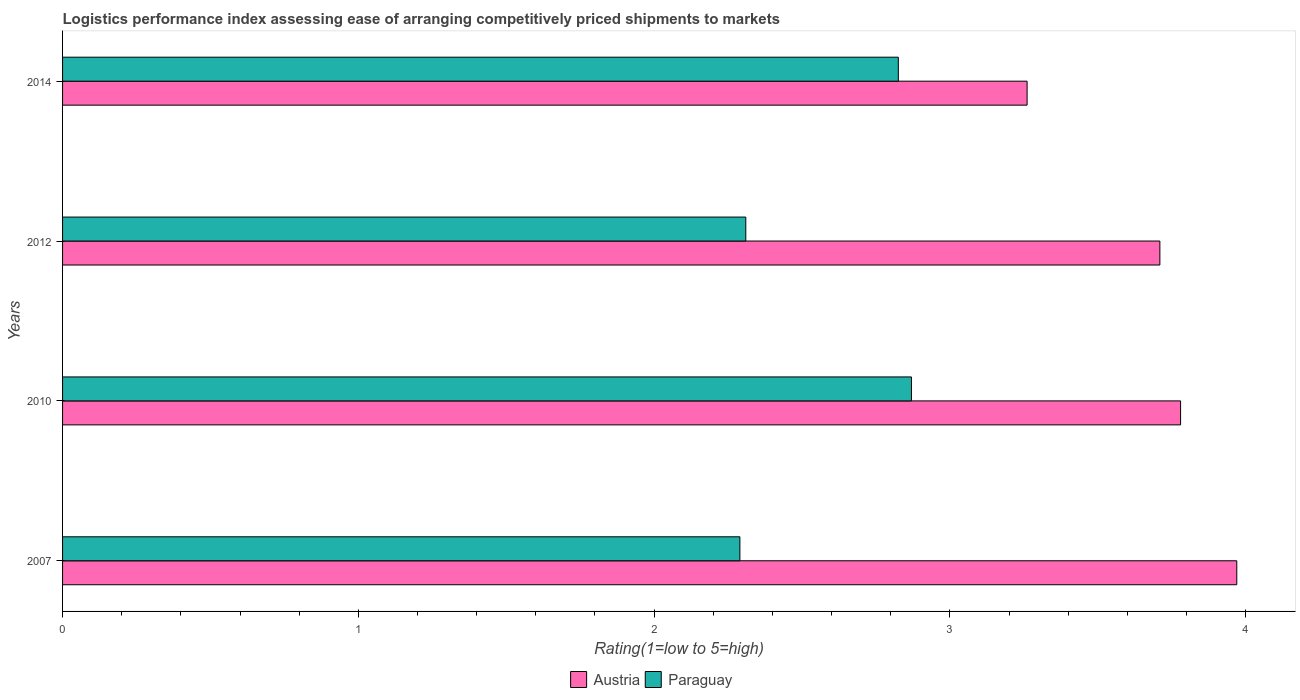How many groups of bars are there?
Ensure brevity in your answer.  4. Are the number of bars on each tick of the Y-axis equal?
Provide a succinct answer. Yes. In how many cases, is the number of bars for a given year not equal to the number of legend labels?
Offer a terse response. 0. What is the Logistic performance index in Paraguay in 2012?
Your answer should be very brief. 2.31. Across all years, what is the maximum Logistic performance index in Austria?
Your response must be concise. 3.97. Across all years, what is the minimum Logistic performance index in Austria?
Offer a terse response. 3.26. In which year was the Logistic performance index in Austria minimum?
Offer a terse response. 2014. What is the total Logistic performance index in Paraguay in the graph?
Your answer should be compact. 10.3. What is the difference between the Logistic performance index in Paraguay in 2007 and that in 2012?
Offer a very short reply. -0.02. What is the difference between the Logistic performance index in Paraguay in 2014 and the Logistic performance index in Austria in 2007?
Offer a terse response. -1.14. What is the average Logistic performance index in Austria per year?
Your answer should be compact. 3.68. In the year 2012, what is the difference between the Logistic performance index in Austria and Logistic performance index in Paraguay?
Offer a terse response. 1.4. In how many years, is the Logistic performance index in Paraguay greater than 0.4 ?
Give a very brief answer. 4. What is the ratio of the Logistic performance index in Austria in 2012 to that in 2014?
Your answer should be very brief. 1.14. Is the Logistic performance index in Paraguay in 2007 less than that in 2010?
Offer a terse response. Yes. Is the difference between the Logistic performance index in Austria in 2010 and 2014 greater than the difference between the Logistic performance index in Paraguay in 2010 and 2014?
Provide a succinct answer. Yes. What is the difference between the highest and the second highest Logistic performance index in Paraguay?
Your answer should be very brief. 0.04. What is the difference between the highest and the lowest Logistic performance index in Paraguay?
Offer a terse response. 0.58. In how many years, is the Logistic performance index in Paraguay greater than the average Logistic performance index in Paraguay taken over all years?
Your answer should be compact. 2. What does the 1st bar from the top in 2014 represents?
Offer a terse response. Paraguay. What does the 1st bar from the bottom in 2007 represents?
Provide a short and direct response. Austria. How many bars are there?
Your response must be concise. 8. How many years are there in the graph?
Give a very brief answer. 4. What is the difference between two consecutive major ticks on the X-axis?
Give a very brief answer. 1. Does the graph contain any zero values?
Provide a succinct answer. No. Does the graph contain grids?
Offer a very short reply. No. Where does the legend appear in the graph?
Provide a short and direct response. Bottom center. What is the title of the graph?
Provide a succinct answer. Logistics performance index assessing ease of arranging competitively priced shipments to markets. Does "Senegal" appear as one of the legend labels in the graph?
Your response must be concise. No. What is the label or title of the X-axis?
Ensure brevity in your answer.  Rating(1=low to 5=high). What is the Rating(1=low to 5=high) of Austria in 2007?
Ensure brevity in your answer.  3.97. What is the Rating(1=low to 5=high) of Paraguay in 2007?
Keep it short and to the point. 2.29. What is the Rating(1=low to 5=high) in Austria in 2010?
Your answer should be very brief. 3.78. What is the Rating(1=low to 5=high) of Paraguay in 2010?
Offer a very short reply. 2.87. What is the Rating(1=low to 5=high) in Austria in 2012?
Offer a very short reply. 3.71. What is the Rating(1=low to 5=high) in Paraguay in 2012?
Your response must be concise. 2.31. What is the Rating(1=low to 5=high) of Austria in 2014?
Ensure brevity in your answer.  3.26. What is the Rating(1=low to 5=high) in Paraguay in 2014?
Provide a succinct answer. 2.83. Across all years, what is the maximum Rating(1=low to 5=high) of Austria?
Give a very brief answer. 3.97. Across all years, what is the maximum Rating(1=low to 5=high) of Paraguay?
Provide a succinct answer. 2.87. Across all years, what is the minimum Rating(1=low to 5=high) in Austria?
Offer a very short reply. 3.26. Across all years, what is the minimum Rating(1=low to 5=high) of Paraguay?
Make the answer very short. 2.29. What is the total Rating(1=low to 5=high) in Austria in the graph?
Your answer should be very brief. 14.72. What is the total Rating(1=low to 5=high) of Paraguay in the graph?
Your response must be concise. 10.3. What is the difference between the Rating(1=low to 5=high) of Austria in 2007 and that in 2010?
Your answer should be very brief. 0.19. What is the difference between the Rating(1=low to 5=high) in Paraguay in 2007 and that in 2010?
Give a very brief answer. -0.58. What is the difference between the Rating(1=low to 5=high) in Austria in 2007 and that in 2012?
Your response must be concise. 0.26. What is the difference between the Rating(1=low to 5=high) of Paraguay in 2007 and that in 2012?
Ensure brevity in your answer.  -0.02. What is the difference between the Rating(1=low to 5=high) in Austria in 2007 and that in 2014?
Provide a succinct answer. 0.71. What is the difference between the Rating(1=low to 5=high) of Paraguay in 2007 and that in 2014?
Ensure brevity in your answer.  -0.54. What is the difference between the Rating(1=low to 5=high) of Austria in 2010 and that in 2012?
Keep it short and to the point. 0.07. What is the difference between the Rating(1=low to 5=high) of Paraguay in 2010 and that in 2012?
Your response must be concise. 0.56. What is the difference between the Rating(1=low to 5=high) in Austria in 2010 and that in 2014?
Make the answer very short. 0.52. What is the difference between the Rating(1=low to 5=high) in Paraguay in 2010 and that in 2014?
Your answer should be very brief. 0.04. What is the difference between the Rating(1=low to 5=high) in Austria in 2012 and that in 2014?
Make the answer very short. 0.45. What is the difference between the Rating(1=low to 5=high) of Paraguay in 2012 and that in 2014?
Ensure brevity in your answer.  -0.52. What is the difference between the Rating(1=low to 5=high) in Austria in 2007 and the Rating(1=low to 5=high) in Paraguay in 2012?
Offer a terse response. 1.66. What is the difference between the Rating(1=low to 5=high) in Austria in 2007 and the Rating(1=low to 5=high) in Paraguay in 2014?
Keep it short and to the point. 1.14. What is the difference between the Rating(1=low to 5=high) of Austria in 2010 and the Rating(1=low to 5=high) of Paraguay in 2012?
Your response must be concise. 1.47. What is the difference between the Rating(1=low to 5=high) in Austria in 2010 and the Rating(1=low to 5=high) in Paraguay in 2014?
Give a very brief answer. 0.95. What is the difference between the Rating(1=low to 5=high) in Austria in 2012 and the Rating(1=low to 5=high) in Paraguay in 2014?
Offer a terse response. 0.88. What is the average Rating(1=low to 5=high) in Austria per year?
Ensure brevity in your answer.  3.68. What is the average Rating(1=low to 5=high) in Paraguay per year?
Ensure brevity in your answer.  2.57. In the year 2007, what is the difference between the Rating(1=low to 5=high) in Austria and Rating(1=low to 5=high) in Paraguay?
Ensure brevity in your answer.  1.68. In the year 2010, what is the difference between the Rating(1=low to 5=high) in Austria and Rating(1=low to 5=high) in Paraguay?
Ensure brevity in your answer.  0.91. In the year 2014, what is the difference between the Rating(1=low to 5=high) of Austria and Rating(1=low to 5=high) of Paraguay?
Provide a short and direct response. 0.44. What is the ratio of the Rating(1=low to 5=high) of Austria in 2007 to that in 2010?
Your answer should be compact. 1.05. What is the ratio of the Rating(1=low to 5=high) in Paraguay in 2007 to that in 2010?
Your answer should be very brief. 0.8. What is the ratio of the Rating(1=low to 5=high) in Austria in 2007 to that in 2012?
Make the answer very short. 1.07. What is the ratio of the Rating(1=low to 5=high) in Austria in 2007 to that in 2014?
Give a very brief answer. 1.22. What is the ratio of the Rating(1=low to 5=high) in Paraguay in 2007 to that in 2014?
Make the answer very short. 0.81. What is the ratio of the Rating(1=low to 5=high) of Austria in 2010 to that in 2012?
Provide a succinct answer. 1.02. What is the ratio of the Rating(1=low to 5=high) of Paraguay in 2010 to that in 2012?
Make the answer very short. 1.24. What is the ratio of the Rating(1=low to 5=high) in Austria in 2010 to that in 2014?
Make the answer very short. 1.16. What is the ratio of the Rating(1=low to 5=high) of Paraguay in 2010 to that in 2014?
Your answer should be compact. 1.02. What is the ratio of the Rating(1=low to 5=high) of Austria in 2012 to that in 2014?
Keep it short and to the point. 1.14. What is the ratio of the Rating(1=low to 5=high) in Paraguay in 2012 to that in 2014?
Provide a succinct answer. 0.82. What is the difference between the highest and the second highest Rating(1=low to 5=high) of Austria?
Ensure brevity in your answer.  0.19. What is the difference between the highest and the second highest Rating(1=low to 5=high) in Paraguay?
Provide a short and direct response. 0.04. What is the difference between the highest and the lowest Rating(1=low to 5=high) of Austria?
Give a very brief answer. 0.71. What is the difference between the highest and the lowest Rating(1=low to 5=high) of Paraguay?
Your answer should be compact. 0.58. 